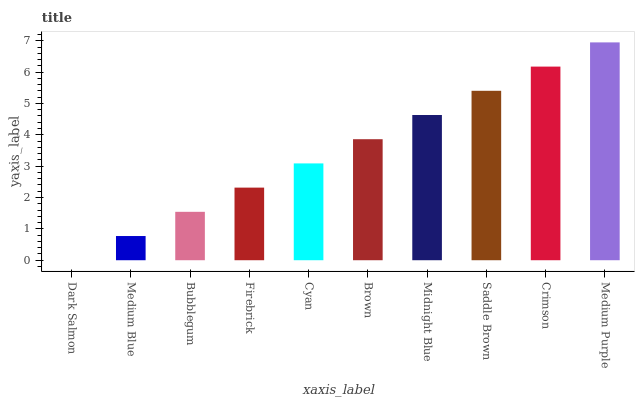Is Dark Salmon the minimum?
Answer yes or no. Yes. Is Medium Purple the maximum?
Answer yes or no. Yes. Is Medium Blue the minimum?
Answer yes or no. No. Is Medium Blue the maximum?
Answer yes or no. No. Is Medium Blue greater than Dark Salmon?
Answer yes or no. Yes. Is Dark Salmon less than Medium Blue?
Answer yes or no. Yes. Is Dark Salmon greater than Medium Blue?
Answer yes or no. No. Is Medium Blue less than Dark Salmon?
Answer yes or no. No. Is Brown the high median?
Answer yes or no. Yes. Is Cyan the low median?
Answer yes or no. Yes. Is Medium Blue the high median?
Answer yes or no. No. Is Crimson the low median?
Answer yes or no. No. 